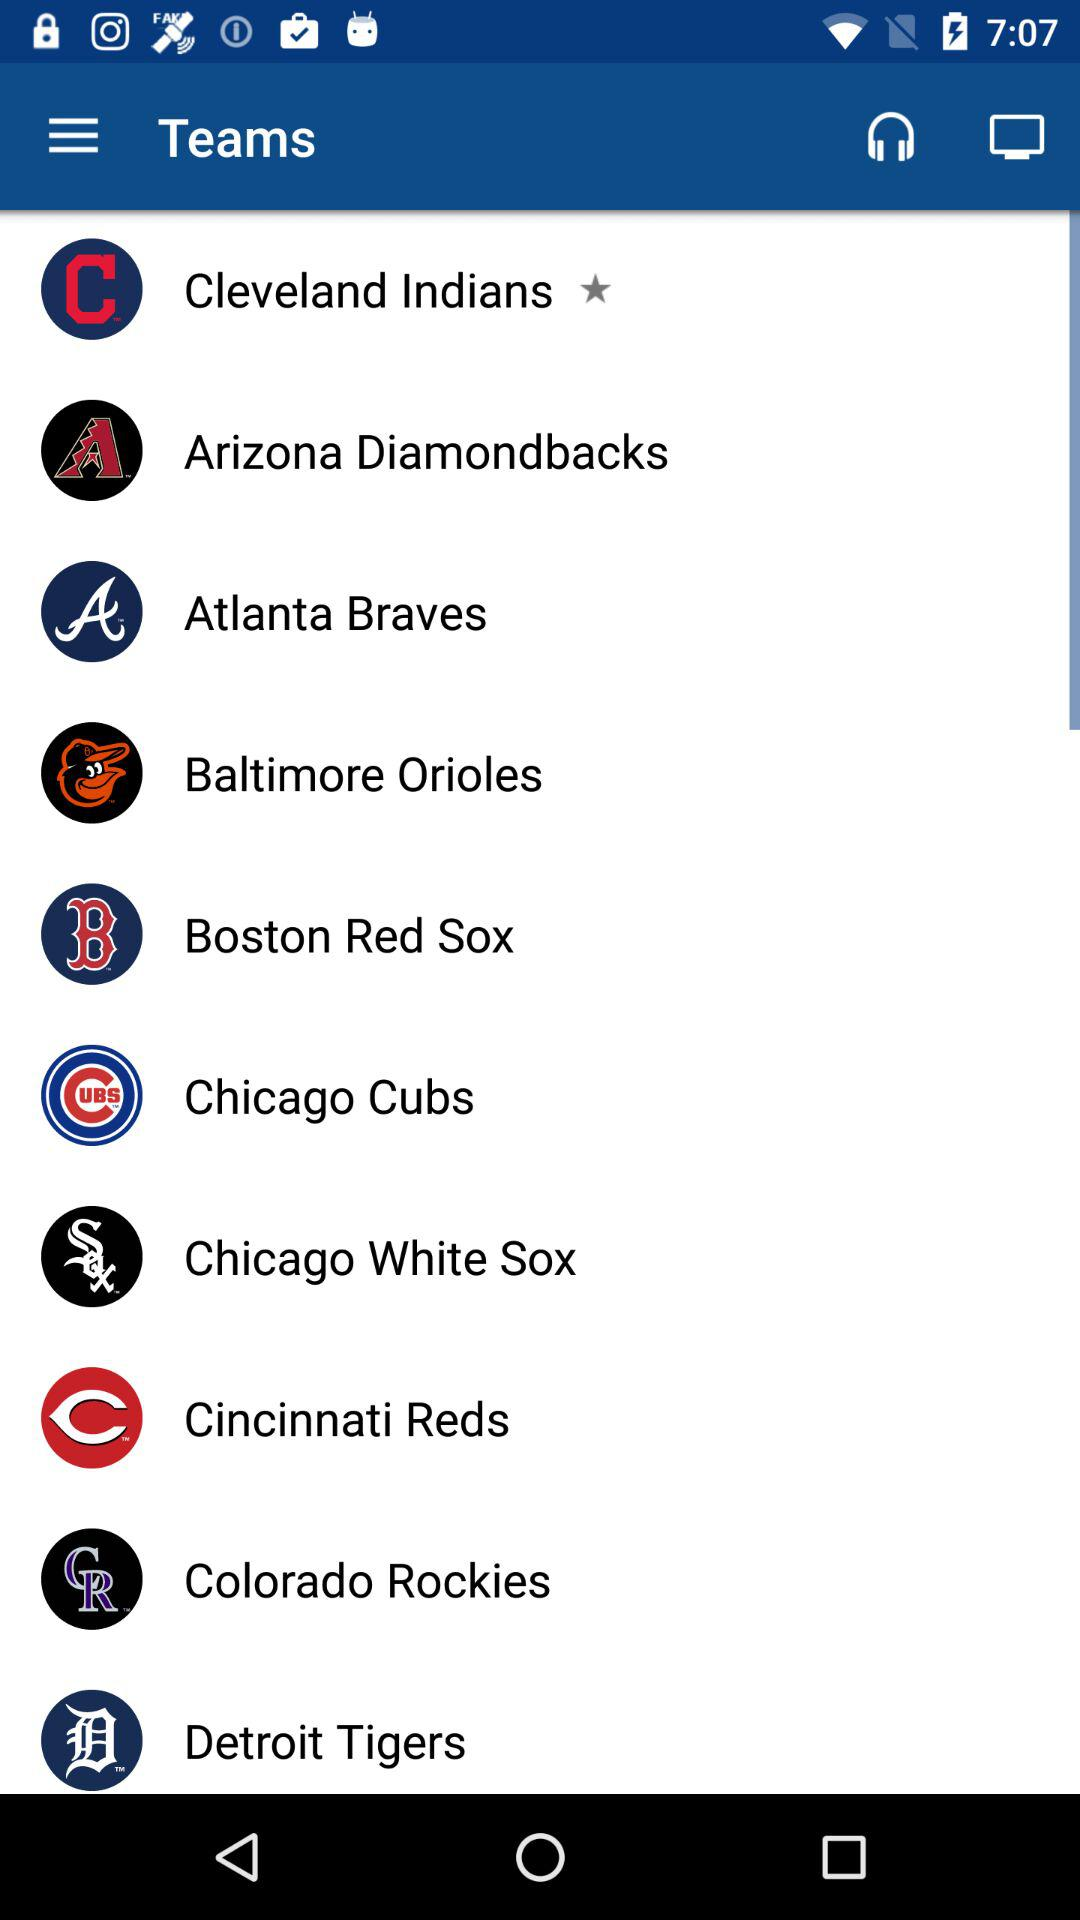Who is this application powered by?
When the provided information is insufficient, respond with <no answer>. <no answer> 